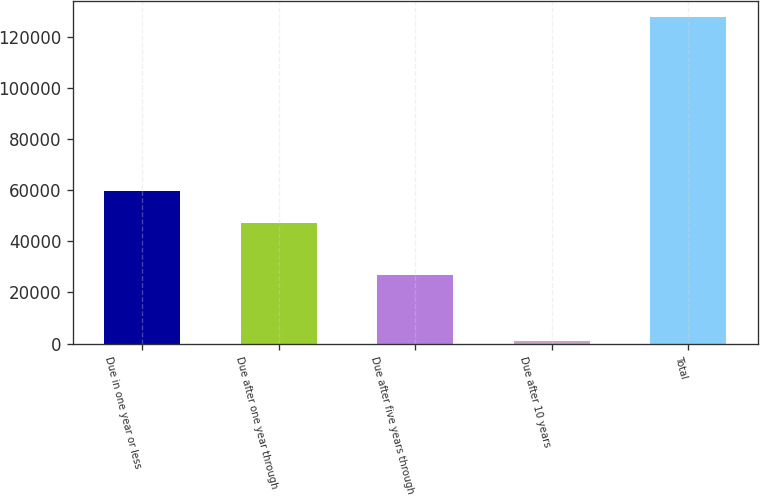Convert chart to OTSL. <chart><loc_0><loc_0><loc_500><loc_500><bar_chart><fcel>Due in one year or less<fcel>Due after one year through<fcel>Due after five years through<fcel>Due after 10 years<fcel>Total<nl><fcel>59703.4<fcel>47016<fcel>26658<fcel>873<fcel>127747<nl></chart> 